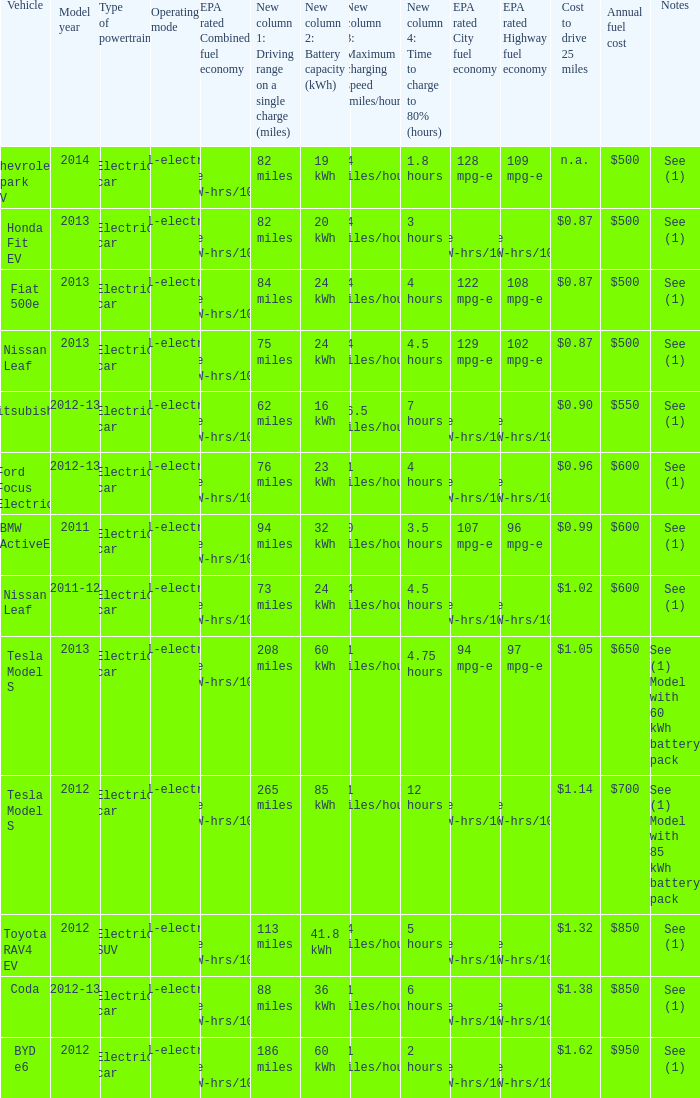What is the epa highway fuel economy for an electric suv? 74 mpg-e (46kW-hrs/100mi). 